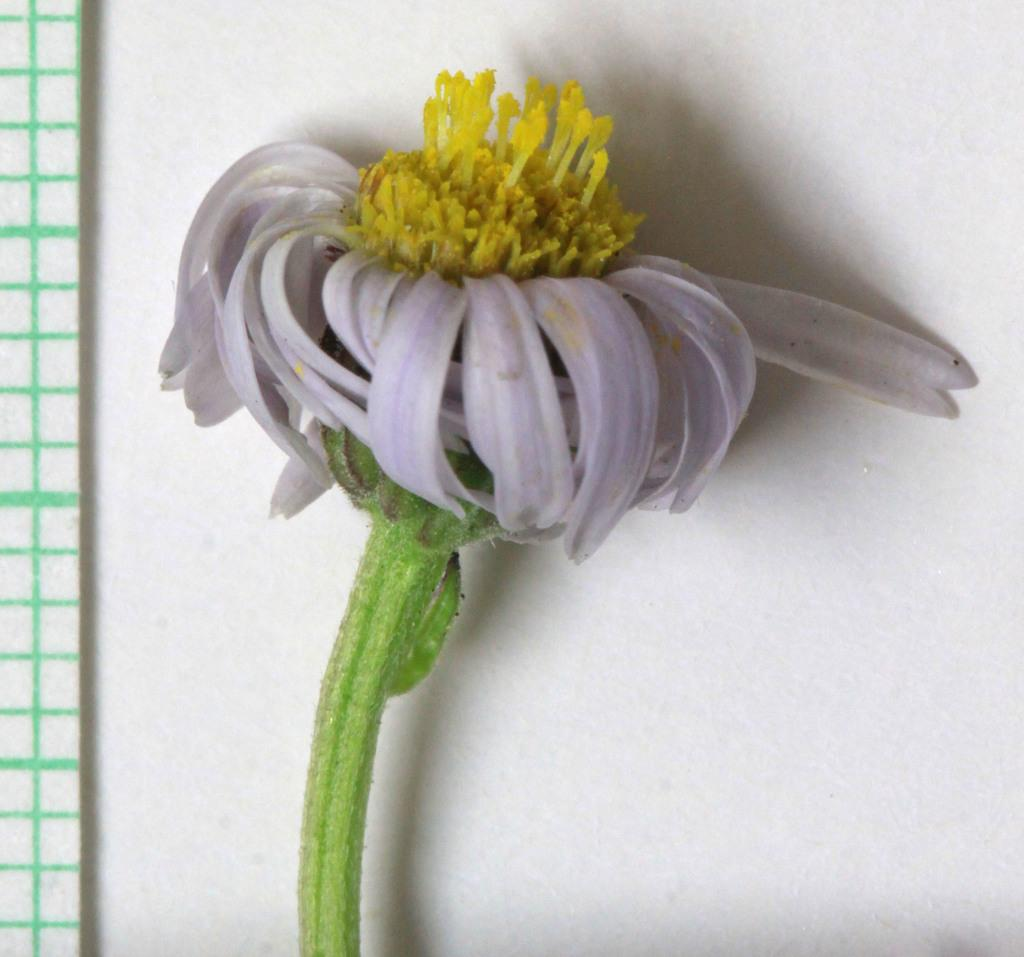What is the main subject in the foreground of the image? There is a flower in the foreground of the image. What is the color of the surface on which the flower is placed? The flower is on a white surface. What can be seen on the left side of the image? There are green lines on the left side of the image. What type of work is being done on the gate in the image? There is no gate present in the image, so no work is being done on a gate. Can you tell me what kind of card is being used to decorate the flower in the image? There is no card present in the image; the flower is simply placed on a white surface. 